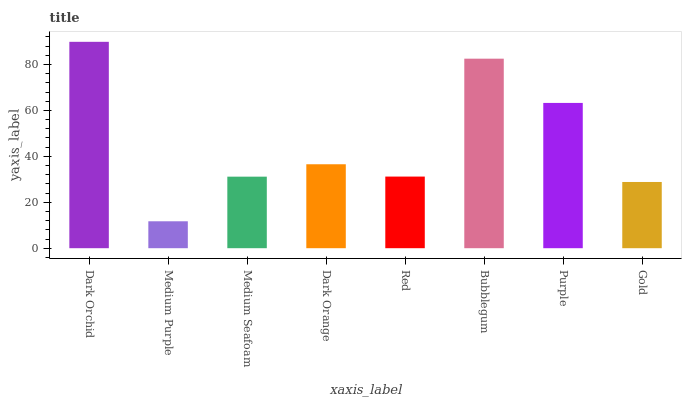Is Medium Purple the minimum?
Answer yes or no. Yes. Is Dark Orchid the maximum?
Answer yes or no. Yes. Is Medium Seafoam the minimum?
Answer yes or no. No. Is Medium Seafoam the maximum?
Answer yes or no. No. Is Medium Seafoam greater than Medium Purple?
Answer yes or no. Yes. Is Medium Purple less than Medium Seafoam?
Answer yes or no. Yes. Is Medium Purple greater than Medium Seafoam?
Answer yes or no. No. Is Medium Seafoam less than Medium Purple?
Answer yes or no. No. Is Dark Orange the high median?
Answer yes or no. Yes. Is Red the low median?
Answer yes or no. Yes. Is Bubblegum the high median?
Answer yes or no. No. Is Dark Orange the low median?
Answer yes or no. No. 